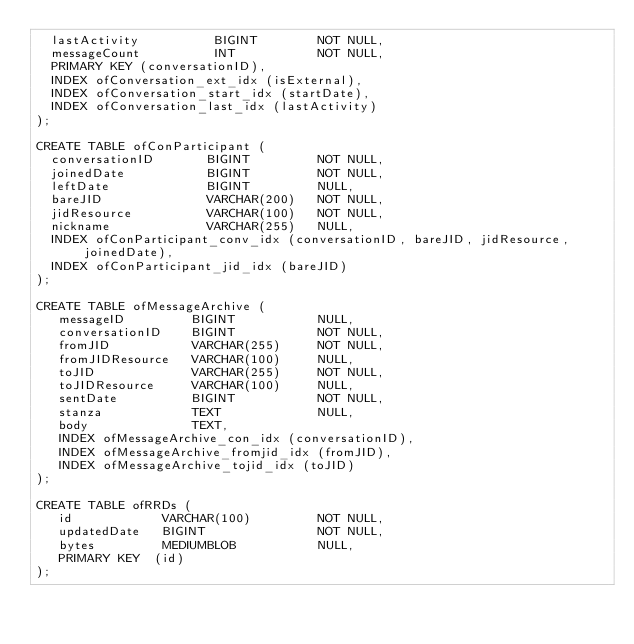<code> <loc_0><loc_0><loc_500><loc_500><_SQL_>  lastActivity          BIGINT        NOT NULL,
  messageCount          INT           NOT NULL,
  PRIMARY KEY (conversationID),
  INDEX ofConversation_ext_idx (isExternal),
  INDEX ofConversation_start_idx (startDate),
  INDEX ofConversation_last_idx (lastActivity)
);

CREATE TABLE ofConParticipant (
  conversationID       BIGINT         NOT NULL,
  joinedDate           BIGINT         NOT NULL,
  leftDate             BIGINT         NULL,
  bareJID              VARCHAR(200)   NOT NULL,
  jidResource          VARCHAR(100)   NOT NULL,
  nickname             VARCHAR(255)   NULL,
  INDEX ofConParticipant_conv_idx (conversationID, bareJID, jidResource, joinedDate),
  INDEX ofConParticipant_jid_idx (bareJID)
);

CREATE TABLE ofMessageArchive (
   messageID		 BIGINT			  NULL,
   conversationID    BIGINT           NOT NULL,
   fromJID           VARCHAR(255)     NOT NULL,
   fromJIDResource   VARCHAR(100)     NULL,
   toJID             VARCHAR(255)     NOT NULL,
   toJIDResource     VARCHAR(100)     NULL,
   sentDate          BIGINT           NOT NULL,
   stanza			 TEXT			  NULL,
   body              TEXT,
   INDEX ofMessageArchive_con_idx (conversationID),
   INDEX ofMessageArchive_fromjid_idx (fromJID),
   INDEX ofMessageArchive_tojid_idx (toJID)
);

CREATE TABLE ofRRDs (
   id            VARCHAR(100)         NOT NULL,
   updatedDate   BIGINT               NOT NULL,
   bytes         MEDIUMBLOB           NULL,
   PRIMARY KEY  (id)
);

</code> 